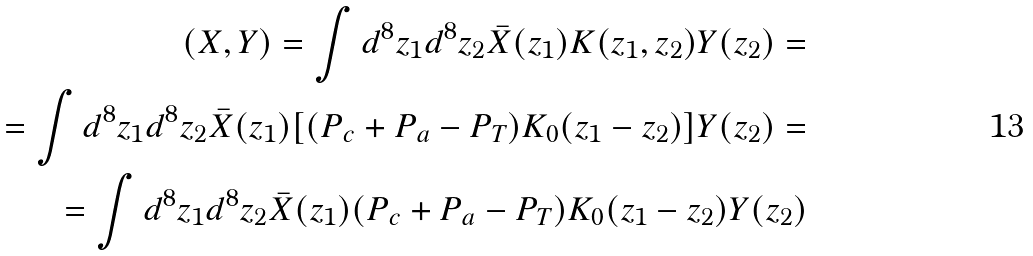Convert formula to latex. <formula><loc_0><loc_0><loc_500><loc_500>( X , Y ) = \int d ^ { 8 } z _ { 1 } d ^ { 8 } z _ { 2 } \bar { X } ( z _ { 1 } ) K ( z _ { 1 } , z _ { 2 } ) Y ( z _ { 2 } ) = \\ = \int d ^ { 8 } z _ { 1 } d ^ { 8 } z _ { 2 } \bar { X } ( z _ { 1 } ) [ ( P _ { c } + P _ { a } - P _ { T } ) K _ { 0 } ( z _ { 1 } - z _ { 2 } ) ] Y ( z _ { 2 } ) = \\ = \int d ^ { 8 } z _ { 1 } d ^ { 8 } z _ { 2 } \bar { X } ( z _ { 1 } ) ( P _ { c } + P _ { a } - P _ { T } ) K _ { 0 } ( z _ { 1 } - z _ { 2 } ) Y ( z _ { 2 } )</formula> 